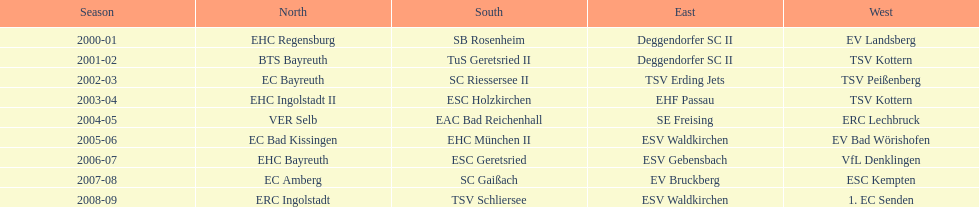In the 2000-01 season, which team was the sole winner of the north? EHC Regensburg. Could you help me parse every detail presented in this table? {'header': ['Season', 'North', 'South', 'East', 'West'], 'rows': [['2000-01', 'EHC Regensburg', 'SB Rosenheim', 'Deggendorfer SC II', 'EV Landsberg'], ['2001-02', 'BTS Bayreuth', 'TuS Geretsried II', 'Deggendorfer SC II', 'TSV Kottern'], ['2002-03', 'EC Bayreuth', 'SC Riessersee II', 'TSV Erding Jets', 'TSV Peißenberg'], ['2003-04', 'EHC Ingolstadt II', 'ESC Holzkirchen', 'EHF Passau', 'TSV Kottern'], ['2004-05', 'VER Selb', 'EAC Bad Reichenhall', 'SE Freising', 'ERC Lechbruck'], ['2005-06', 'EC Bad Kissingen', 'EHC München II', 'ESV Waldkirchen', 'EV Bad Wörishofen'], ['2006-07', 'EHC Bayreuth', 'ESC Geretsried', 'ESV Gebensbach', 'VfL Denklingen'], ['2007-08', 'EC Amberg', 'SC Gaißach', 'EV Bruckberg', 'ESC Kempten'], ['2008-09', 'ERC Ingolstadt', 'TSV Schliersee', 'ESV Waldkirchen', '1. EC Senden']]} 